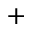Convert formula to latex. <formula><loc_0><loc_0><loc_500><loc_500>^ { + }</formula> 